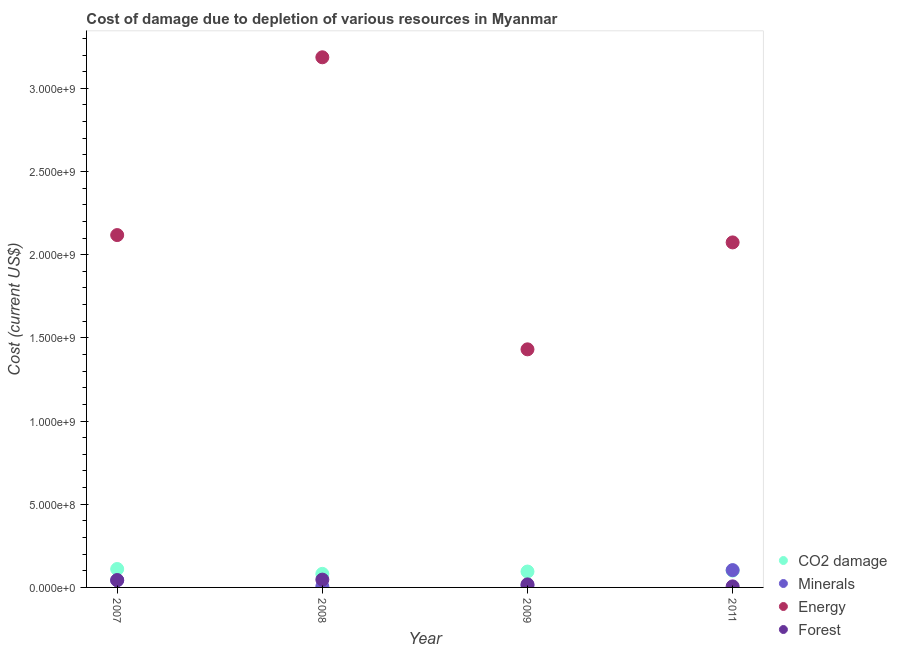Is the number of dotlines equal to the number of legend labels?
Give a very brief answer. Yes. What is the cost of damage due to depletion of forests in 2009?
Provide a short and direct response. 1.83e+07. Across all years, what is the maximum cost of damage due to depletion of coal?
Offer a terse response. 1.11e+08. Across all years, what is the minimum cost of damage due to depletion of coal?
Ensure brevity in your answer.  8.15e+07. In which year was the cost of damage due to depletion of minerals maximum?
Give a very brief answer. 2011. In which year was the cost of damage due to depletion of forests minimum?
Make the answer very short. 2011. What is the total cost of damage due to depletion of energy in the graph?
Give a very brief answer. 8.81e+09. What is the difference between the cost of damage due to depletion of energy in 2007 and that in 2009?
Provide a short and direct response. 6.87e+08. What is the difference between the cost of damage due to depletion of forests in 2009 and the cost of damage due to depletion of coal in 2008?
Provide a succinct answer. -6.31e+07. What is the average cost of damage due to depletion of minerals per year?
Provide a succinct answer. 4.10e+07. In the year 2011, what is the difference between the cost of damage due to depletion of forests and cost of damage due to depletion of energy?
Your answer should be compact. -2.07e+09. What is the ratio of the cost of damage due to depletion of minerals in 2007 to that in 2009?
Give a very brief answer. 3.72. Is the cost of damage due to depletion of forests in 2008 less than that in 2011?
Your response must be concise. No. What is the difference between the highest and the second highest cost of damage due to depletion of minerals?
Ensure brevity in your answer.  6.11e+07. What is the difference between the highest and the lowest cost of damage due to depletion of forests?
Offer a terse response. 4.07e+07. Is the sum of the cost of damage due to depletion of energy in 2008 and 2011 greater than the maximum cost of damage due to depletion of forests across all years?
Make the answer very short. Yes. Does the cost of damage due to depletion of energy monotonically increase over the years?
Provide a short and direct response. No. Is the cost of damage due to depletion of energy strictly greater than the cost of damage due to depletion of forests over the years?
Provide a succinct answer. Yes. What is the difference between two consecutive major ticks on the Y-axis?
Your answer should be very brief. 5.00e+08. Does the graph contain any zero values?
Keep it short and to the point. No. Does the graph contain grids?
Offer a very short reply. No. Where does the legend appear in the graph?
Your answer should be very brief. Bottom right. How are the legend labels stacked?
Your response must be concise. Vertical. What is the title of the graph?
Your answer should be compact. Cost of damage due to depletion of various resources in Myanmar . Does "Sweden" appear as one of the legend labels in the graph?
Make the answer very short. No. What is the label or title of the Y-axis?
Offer a very short reply. Cost (current US$). What is the Cost (current US$) in CO2 damage in 2007?
Offer a terse response. 1.11e+08. What is the Cost (current US$) of Minerals in 2007?
Offer a very short reply. 4.29e+07. What is the Cost (current US$) in Energy in 2007?
Your answer should be very brief. 2.12e+09. What is the Cost (current US$) in Forest in 2007?
Provide a succinct answer. 4.40e+07. What is the Cost (current US$) in CO2 damage in 2008?
Your answer should be compact. 8.15e+07. What is the Cost (current US$) in Minerals in 2008?
Ensure brevity in your answer.  5.68e+06. What is the Cost (current US$) of Energy in 2008?
Offer a terse response. 3.19e+09. What is the Cost (current US$) in Forest in 2008?
Your answer should be compact. 4.70e+07. What is the Cost (current US$) of CO2 damage in 2009?
Provide a succinct answer. 9.55e+07. What is the Cost (current US$) of Minerals in 2009?
Your response must be concise. 1.15e+07. What is the Cost (current US$) in Energy in 2009?
Make the answer very short. 1.43e+09. What is the Cost (current US$) of Forest in 2009?
Make the answer very short. 1.83e+07. What is the Cost (current US$) of CO2 damage in 2011?
Offer a very short reply. 1.01e+08. What is the Cost (current US$) of Minerals in 2011?
Make the answer very short. 1.04e+08. What is the Cost (current US$) of Energy in 2011?
Offer a very short reply. 2.07e+09. What is the Cost (current US$) in Forest in 2011?
Make the answer very short. 6.26e+06. Across all years, what is the maximum Cost (current US$) in CO2 damage?
Offer a very short reply. 1.11e+08. Across all years, what is the maximum Cost (current US$) of Minerals?
Offer a very short reply. 1.04e+08. Across all years, what is the maximum Cost (current US$) of Energy?
Your response must be concise. 3.19e+09. Across all years, what is the maximum Cost (current US$) in Forest?
Your answer should be very brief. 4.70e+07. Across all years, what is the minimum Cost (current US$) in CO2 damage?
Keep it short and to the point. 8.15e+07. Across all years, what is the minimum Cost (current US$) in Minerals?
Offer a very short reply. 5.68e+06. Across all years, what is the minimum Cost (current US$) in Energy?
Provide a succinct answer. 1.43e+09. Across all years, what is the minimum Cost (current US$) of Forest?
Offer a very short reply. 6.26e+06. What is the total Cost (current US$) of CO2 damage in the graph?
Make the answer very short. 3.89e+08. What is the total Cost (current US$) of Minerals in the graph?
Your answer should be compact. 1.64e+08. What is the total Cost (current US$) in Energy in the graph?
Ensure brevity in your answer.  8.81e+09. What is the total Cost (current US$) in Forest in the graph?
Provide a succinct answer. 1.16e+08. What is the difference between the Cost (current US$) in CO2 damage in 2007 and that in 2008?
Your answer should be compact. 2.92e+07. What is the difference between the Cost (current US$) of Minerals in 2007 and that in 2008?
Your answer should be compact. 3.72e+07. What is the difference between the Cost (current US$) of Energy in 2007 and that in 2008?
Provide a short and direct response. -1.07e+09. What is the difference between the Cost (current US$) in Forest in 2007 and that in 2008?
Offer a very short reply. -2.94e+06. What is the difference between the Cost (current US$) of CO2 damage in 2007 and that in 2009?
Your answer should be compact. 1.52e+07. What is the difference between the Cost (current US$) of Minerals in 2007 and that in 2009?
Give a very brief answer. 3.14e+07. What is the difference between the Cost (current US$) of Energy in 2007 and that in 2009?
Your answer should be very brief. 6.87e+08. What is the difference between the Cost (current US$) in Forest in 2007 and that in 2009?
Your answer should be compact. 2.57e+07. What is the difference between the Cost (current US$) in CO2 damage in 2007 and that in 2011?
Ensure brevity in your answer.  9.48e+06. What is the difference between the Cost (current US$) in Minerals in 2007 and that in 2011?
Ensure brevity in your answer.  -6.11e+07. What is the difference between the Cost (current US$) in Energy in 2007 and that in 2011?
Provide a short and direct response. 4.41e+07. What is the difference between the Cost (current US$) in Forest in 2007 and that in 2011?
Make the answer very short. 3.78e+07. What is the difference between the Cost (current US$) of CO2 damage in 2008 and that in 2009?
Give a very brief answer. -1.40e+07. What is the difference between the Cost (current US$) of Minerals in 2008 and that in 2009?
Offer a very short reply. -5.85e+06. What is the difference between the Cost (current US$) of Energy in 2008 and that in 2009?
Provide a succinct answer. 1.76e+09. What is the difference between the Cost (current US$) in Forest in 2008 and that in 2009?
Offer a very short reply. 2.86e+07. What is the difference between the Cost (current US$) in CO2 damage in 2008 and that in 2011?
Your response must be concise. -1.97e+07. What is the difference between the Cost (current US$) of Minerals in 2008 and that in 2011?
Offer a terse response. -9.83e+07. What is the difference between the Cost (current US$) in Energy in 2008 and that in 2011?
Ensure brevity in your answer.  1.11e+09. What is the difference between the Cost (current US$) of Forest in 2008 and that in 2011?
Give a very brief answer. 4.07e+07. What is the difference between the Cost (current US$) in CO2 damage in 2009 and that in 2011?
Ensure brevity in your answer.  -5.74e+06. What is the difference between the Cost (current US$) in Minerals in 2009 and that in 2011?
Your answer should be very brief. -9.25e+07. What is the difference between the Cost (current US$) of Energy in 2009 and that in 2011?
Offer a terse response. -6.43e+08. What is the difference between the Cost (current US$) of Forest in 2009 and that in 2011?
Offer a terse response. 1.21e+07. What is the difference between the Cost (current US$) of CO2 damage in 2007 and the Cost (current US$) of Minerals in 2008?
Make the answer very short. 1.05e+08. What is the difference between the Cost (current US$) of CO2 damage in 2007 and the Cost (current US$) of Energy in 2008?
Your response must be concise. -3.08e+09. What is the difference between the Cost (current US$) of CO2 damage in 2007 and the Cost (current US$) of Forest in 2008?
Ensure brevity in your answer.  6.37e+07. What is the difference between the Cost (current US$) of Minerals in 2007 and the Cost (current US$) of Energy in 2008?
Ensure brevity in your answer.  -3.14e+09. What is the difference between the Cost (current US$) in Minerals in 2007 and the Cost (current US$) in Forest in 2008?
Your response must be concise. -4.07e+06. What is the difference between the Cost (current US$) in Energy in 2007 and the Cost (current US$) in Forest in 2008?
Your answer should be compact. 2.07e+09. What is the difference between the Cost (current US$) in CO2 damage in 2007 and the Cost (current US$) in Minerals in 2009?
Provide a short and direct response. 9.91e+07. What is the difference between the Cost (current US$) in CO2 damage in 2007 and the Cost (current US$) in Energy in 2009?
Your answer should be compact. -1.32e+09. What is the difference between the Cost (current US$) of CO2 damage in 2007 and the Cost (current US$) of Forest in 2009?
Make the answer very short. 9.23e+07. What is the difference between the Cost (current US$) of Minerals in 2007 and the Cost (current US$) of Energy in 2009?
Offer a very short reply. -1.39e+09. What is the difference between the Cost (current US$) of Minerals in 2007 and the Cost (current US$) of Forest in 2009?
Provide a succinct answer. 2.46e+07. What is the difference between the Cost (current US$) in Energy in 2007 and the Cost (current US$) in Forest in 2009?
Offer a terse response. 2.10e+09. What is the difference between the Cost (current US$) in CO2 damage in 2007 and the Cost (current US$) in Minerals in 2011?
Your response must be concise. 6.65e+06. What is the difference between the Cost (current US$) of CO2 damage in 2007 and the Cost (current US$) of Energy in 2011?
Provide a short and direct response. -1.96e+09. What is the difference between the Cost (current US$) in CO2 damage in 2007 and the Cost (current US$) in Forest in 2011?
Your answer should be compact. 1.04e+08. What is the difference between the Cost (current US$) of Minerals in 2007 and the Cost (current US$) of Energy in 2011?
Ensure brevity in your answer.  -2.03e+09. What is the difference between the Cost (current US$) of Minerals in 2007 and the Cost (current US$) of Forest in 2011?
Offer a terse response. 3.66e+07. What is the difference between the Cost (current US$) of Energy in 2007 and the Cost (current US$) of Forest in 2011?
Provide a short and direct response. 2.11e+09. What is the difference between the Cost (current US$) in CO2 damage in 2008 and the Cost (current US$) in Minerals in 2009?
Your answer should be compact. 6.99e+07. What is the difference between the Cost (current US$) of CO2 damage in 2008 and the Cost (current US$) of Energy in 2009?
Your response must be concise. -1.35e+09. What is the difference between the Cost (current US$) of CO2 damage in 2008 and the Cost (current US$) of Forest in 2009?
Provide a short and direct response. 6.31e+07. What is the difference between the Cost (current US$) in Minerals in 2008 and the Cost (current US$) in Energy in 2009?
Offer a terse response. -1.43e+09. What is the difference between the Cost (current US$) of Minerals in 2008 and the Cost (current US$) of Forest in 2009?
Offer a terse response. -1.27e+07. What is the difference between the Cost (current US$) of Energy in 2008 and the Cost (current US$) of Forest in 2009?
Provide a short and direct response. 3.17e+09. What is the difference between the Cost (current US$) of CO2 damage in 2008 and the Cost (current US$) of Minerals in 2011?
Provide a short and direct response. -2.26e+07. What is the difference between the Cost (current US$) of CO2 damage in 2008 and the Cost (current US$) of Energy in 2011?
Offer a very short reply. -1.99e+09. What is the difference between the Cost (current US$) in CO2 damage in 2008 and the Cost (current US$) in Forest in 2011?
Your response must be concise. 7.52e+07. What is the difference between the Cost (current US$) in Minerals in 2008 and the Cost (current US$) in Energy in 2011?
Your answer should be compact. -2.07e+09. What is the difference between the Cost (current US$) of Minerals in 2008 and the Cost (current US$) of Forest in 2011?
Ensure brevity in your answer.  -5.76e+05. What is the difference between the Cost (current US$) in Energy in 2008 and the Cost (current US$) in Forest in 2011?
Make the answer very short. 3.18e+09. What is the difference between the Cost (current US$) of CO2 damage in 2009 and the Cost (current US$) of Minerals in 2011?
Keep it short and to the point. -8.57e+06. What is the difference between the Cost (current US$) of CO2 damage in 2009 and the Cost (current US$) of Energy in 2011?
Offer a terse response. -1.98e+09. What is the difference between the Cost (current US$) in CO2 damage in 2009 and the Cost (current US$) in Forest in 2011?
Offer a terse response. 8.92e+07. What is the difference between the Cost (current US$) of Minerals in 2009 and the Cost (current US$) of Energy in 2011?
Offer a terse response. -2.06e+09. What is the difference between the Cost (current US$) of Minerals in 2009 and the Cost (current US$) of Forest in 2011?
Your answer should be very brief. 5.27e+06. What is the difference between the Cost (current US$) of Energy in 2009 and the Cost (current US$) of Forest in 2011?
Make the answer very short. 1.42e+09. What is the average Cost (current US$) of CO2 damage per year?
Provide a short and direct response. 9.72e+07. What is the average Cost (current US$) of Minerals per year?
Your response must be concise. 4.10e+07. What is the average Cost (current US$) in Energy per year?
Make the answer very short. 2.20e+09. What is the average Cost (current US$) in Forest per year?
Provide a short and direct response. 2.89e+07. In the year 2007, what is the difference between the Cost (current US$) in CO2 damage and Cost (current US$) in Minerals?
Your answer should be very brief. 6.78e+07. In the year 2007, what is the difference between the Cost (current US$) of CO2 damage and Cost (current US$) of Energy?
Your answer should be compact. -2.01e+09. In the year 2007, what is the difference between the Cost (current US$) in CO2 damage and Cost (current US$) in Forest?
Keep it short and to the point. 6.66e+07. In the year 2007, what is the difference between the Cost (current US$) in Minerals and Cost (current US$) in Energy?
Your response must be concise. -2.07e+09. In the year 2007, what is the difference between the Cost (current US$) of Minerals and Cost (current US$) of Forest?
Offer a very short reply. -1.13e+06. In the year 2007, what is the difference between the Cost (current US$) in Energy and Cost (current US$) in Forest?
Ensure brevity in your answer.  2.07e+09. In the year 2008, what is the difference between the Cost (current US$) of CO2 damage and Cost (current US$) of Minerals?
Provide a succinct answer. 7.58e+07. In the year 2008, what is the difference between the Cost (current US$) of CO2 damage and Cost (current US$) of Energy?
Give a very brief answer. -3.10e+09. In the year 2008, what is the difference between the Cost (current US$) of CO2 damage and Cost (current US$) of Forest?
Give a very brief answer. 3.45e+07. In the year 2008, what is the difference between the Cost (current US$) in Minerals and Cost (current US$) in Energy?
Give a very brief answer. -3.18e+09. In the year 2008, what is the difference between the Cost (current US$) of Minerals and Cost (current US$) of Forest?
Ensure brevity in your answer.  -4.13e+07. In the year 2008, what is the difference between the Cost (current US$) in Energy and Cost (current US$) in Forest?
Ensure brevity in your answer.  3.14e+09. In the year 2009, what is the difference between the Cost (current US$) in CO2 damage and Cost (current US$) in Minerals?
Give a very brief answer. 8.39e+07. In the year 2009, what is the difference between the Cost (current US$) in CO2 damage and Cost (current US$) in Energy?
Make the answer very short. -1.34e+09. In the year 2009, what is the difference between the Cost (current US$) in CO2 damage and Cost (current US$) in Forest?
Offer a terse response. 7.71e+07. In the year 2009, what is the difference between the Cost (current US$) of Minerals and Cost (current US$) of Energy?
Make the answer very short. -1.42e+09. In the year 2009, what is the difference between the Cost (current US$) of Minerals and Cost (current US$) of Forest?
Keep it short and to the point. -6.80e+06. In the year 2009, what is the difference between the Cost (current US$) of Energy and Cost (current US$) of Forest?
Keep it short and to the point. 1.41e+09. In the year 2011, what is the difference between the Cost (current US$) in CO2 damage and Cost (current US$) in Minerals?
Give a very brief answer. -2.83e+06. In the year 2011, what is the difference between the Cost (current US$) in CO2 damage and Cost (current US$) in Energy?
Provide a short and direct response. -1.97e+09. In the year 2011, what is the difference between the Cost (current US$) in CO2 damage and Cost (current US$) in Forest?
Make the answer very short. 9.49e+07. In the year 2011, what is the difference between the Cost (current US$) of Minerals and Cost (current US$) of Energy?
Your answer should be compact. -1.97e+09. In the year 2011, what is the difference between the Cost (current US$) in Minerals and Cost (current US$) in Forest?
Offer a terse response. 9.78e+07. In the year 2011, what is the difference between the Cost (current US$) of Energy and Cost (current US$) of Forest?
Your answer should be compact. 2.07e+09. What is the ratio of the Cost (current US$) in CO2 damage in 2007 to that in 2008?
Make the answer very short. 1.36. What is the ratio of the Cost (current US$) in Minerals in 2007 to that in 2008?
Your answer should be very brief. 7.55. What is the ratio of the Cost (current US$) of Energy in 2007 to that in 2008?
Your response must be concise. 0.66. What is the ratio of the Cost (current US$) in Forest in 2007 to that in 2008?
Give a very brief answer. 0.94. What is the ratio of the Cost (current US$) in CO2 damage in 2007 to that in 2009?
Offer a very short reply. 1.16. What is the ratio of the Cost (current US$) in Minerals in 2007 to that in 2009?
Your answer should be compact. 3.72. What is the ratio of the Cost (current US$) of Energy in 2007 to that in 2009?
Keep it short and to the point. 1.48. What is the ratio of the Cost (current US$) in Forest in 2007 to that in 2009?
Give a very brief answer. 2.4. What is the ratio of the Cost (current US$) in CO2 damage in 2007 to that in 2011?
Offer a very short reply. 1.09. What is the ratio of the Cost (current US$) of Minerals in 2007 to that in 2011?
Your answer should be compact. 0.41. What is the ratio of the Cost (current US$) in Energy in 2007 to that in 2011?
Your response must be concise. 1.02. What is the ratio of the Cost (current US$) of Forest in 2007 to that in 2011?
Make the answer very short. 7.04. What is the ratio of the Cost (current US$) of CO2 damage in 2008 to that in 2009?
Provide a succinct answer. 0.85. What is the ratio of the Cost (current US$) in Minerals in 2008 to that in 2009?
Make the answer very short. 0.49. What is the ratio of the Cost (current US$) in Energy in 2008 to that in 2009?
Keep it short and to the point. 2.23. What is the ratio of the Cost (current US$) of Forest in 2008 to that in 2009?
Offer a terse response. 2.56. What is the ratio of the Cost (current US$) in CO2 damage in 2008 to that in 2011?
Give a very brief answer. 0.81. What is the ratio of the Cost (current US$) in Minerals in 2008 to that in 2011?
Make the answer very short. 0.05. What is the ratio of the Cost (current US$) of Energy in 2008 to that in 2011?
Offer a very short reply. 1.54. What is the ratio of the Cost (current US$) of Forest in 2008 to that in 2011?
Your answer should be compact. 7.51. What is the ratio of the Cost (current US$) in CO2 damage in 2009 to that in 2011?
Give a very brief answer. 0.94. What is the ratio of the Cost (current US$) of Minerals in 2009 to that in 2011?
Offer a terse response. 0.11. What is the ratio of the Cost (current US$) of Energy in 2009 to that in 2011?
Your answer should be compact. 0.69. What is the ratio of the Cost (current US$) in Forest in 2009 to that in 2011?
Your answer should be compact. 2.93. What is the difference between the highest and the second highest Cost (current US$) in CO2 damage?
Offer a terse response. 9.48e+06. What is the difference between the highest and the second highest Cost (current US$) in Minerals?
Provide a succinct answer. 6.11e+07. What is the difference between the highest and the second highest Cost (current US$) of Energy?
Provide a succinct answer. 1.07e+09. What is the difference between the highest and the second highest Cost (current US$) of Forest?
Ensure brevity in your answer.  2.94e+06. What is the difference between the highest and the lowest Cost (current US$) of CO2 damage?
Your answer should be compact. 2.92e+07. What is the difference between the highest and the lowest Cost (current US$) of Minerals?
Keep it short and to the point. 9.83e+07. What is the difference between the highest and the lowest Cost (current US$) of Energy?
Give a very brief answer. 1.76e+09. What is the difference between the highest and the lowest Cost (current US$) in Forest?
Provide a short and direct response. 4.07e+07. 